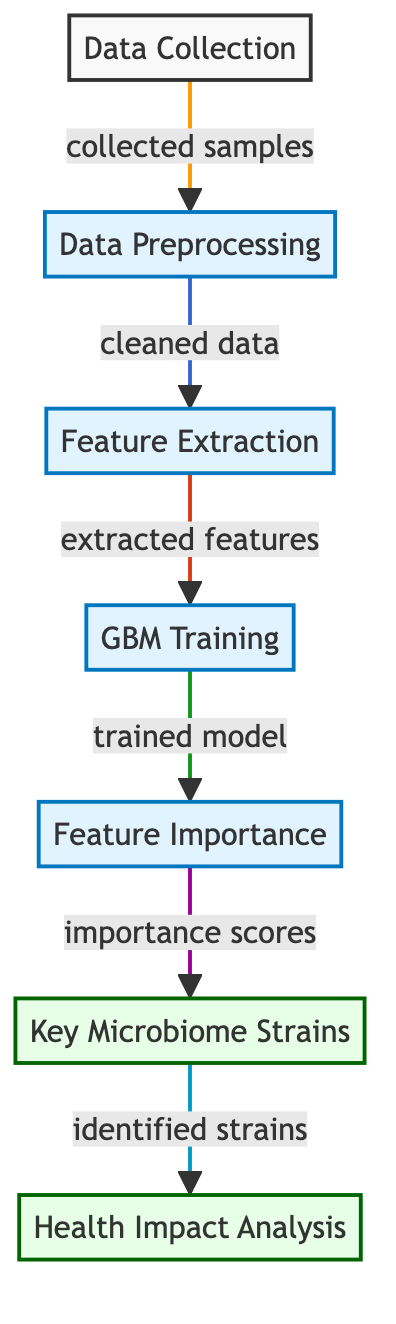What is the starting point of the diagram? The diagram begins at the "Data Collection" node, which indicates the initial stage of gathering samples necessary for analysis.
Answer: Data Collection How many main processes are depicted in the diagram? The diagram presents six distinct processes from "Data Preprocessing" to "Health Impact Analysis" which comprise the entire workflow.
Answer: Six What is the output of the "Feature Importance" process? This process yields "importance scores" that help identify how significant different features are in influencing health outcomes, ultimately guiding further steps.
Answer: Importance scores Which process follows "GBM Training"? Immediately after "GBM Training," the next step in the diagram is "Feature Importance," highlighting the output derived from the training phase.
Answer: Feature Importance What happens after identifying key microbiome strains? The next logical step following the identification of key microbiome strains is the "Health Impact Analysis," where the influence of these strains on health is explored.
Answer: Health Impact Analysis Why is "Data Preprocessing" necessary in this workflow? "Data Preprocessing" is crucial because it involves cleaning data, which ensures that the dataset is reliable and accurate before further analysis and model training begin.
Answer: Cleaning data What determines the key microbiome strains in the diagram? The key microbiome strains are determined by the "Feature Importance" stage, which assesses and ranks features based on their significance in predicting health outcomes.
Answer: Feature Importance Which node represents the final stage of the analysis? The final stage of the analysis is represented by the "Health Impact Analysis" node, where the outcomes of the study are interpreted in terms of health implications.
Answer: Health Impact Analysis What is the primary function of the "Feature Extraction" process? The primary function of "Feature Extraction" is to isolate and select relevant features from the raw data that can then be utilized effectively in model training.
Answer: Extracted features 